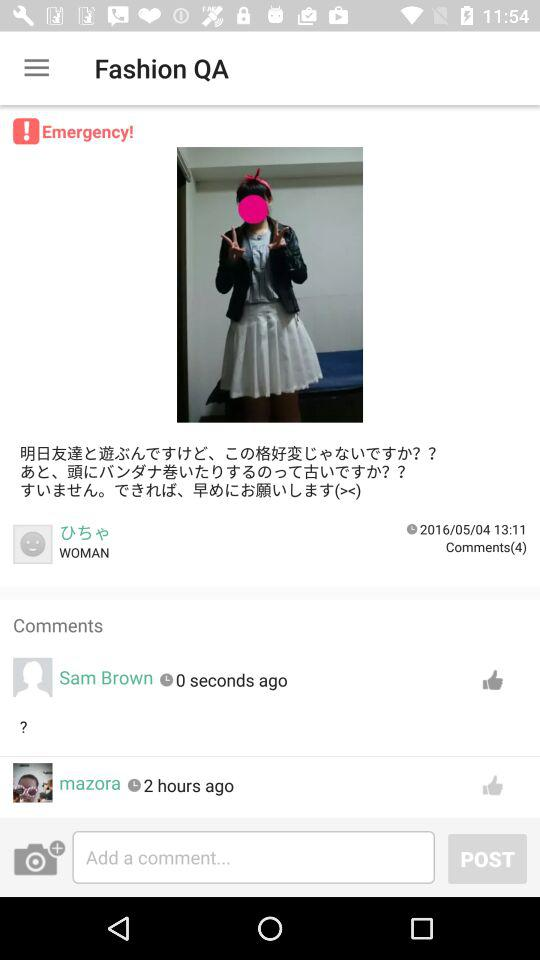What is the name of the application? The name of the application is "Fashion QA". 